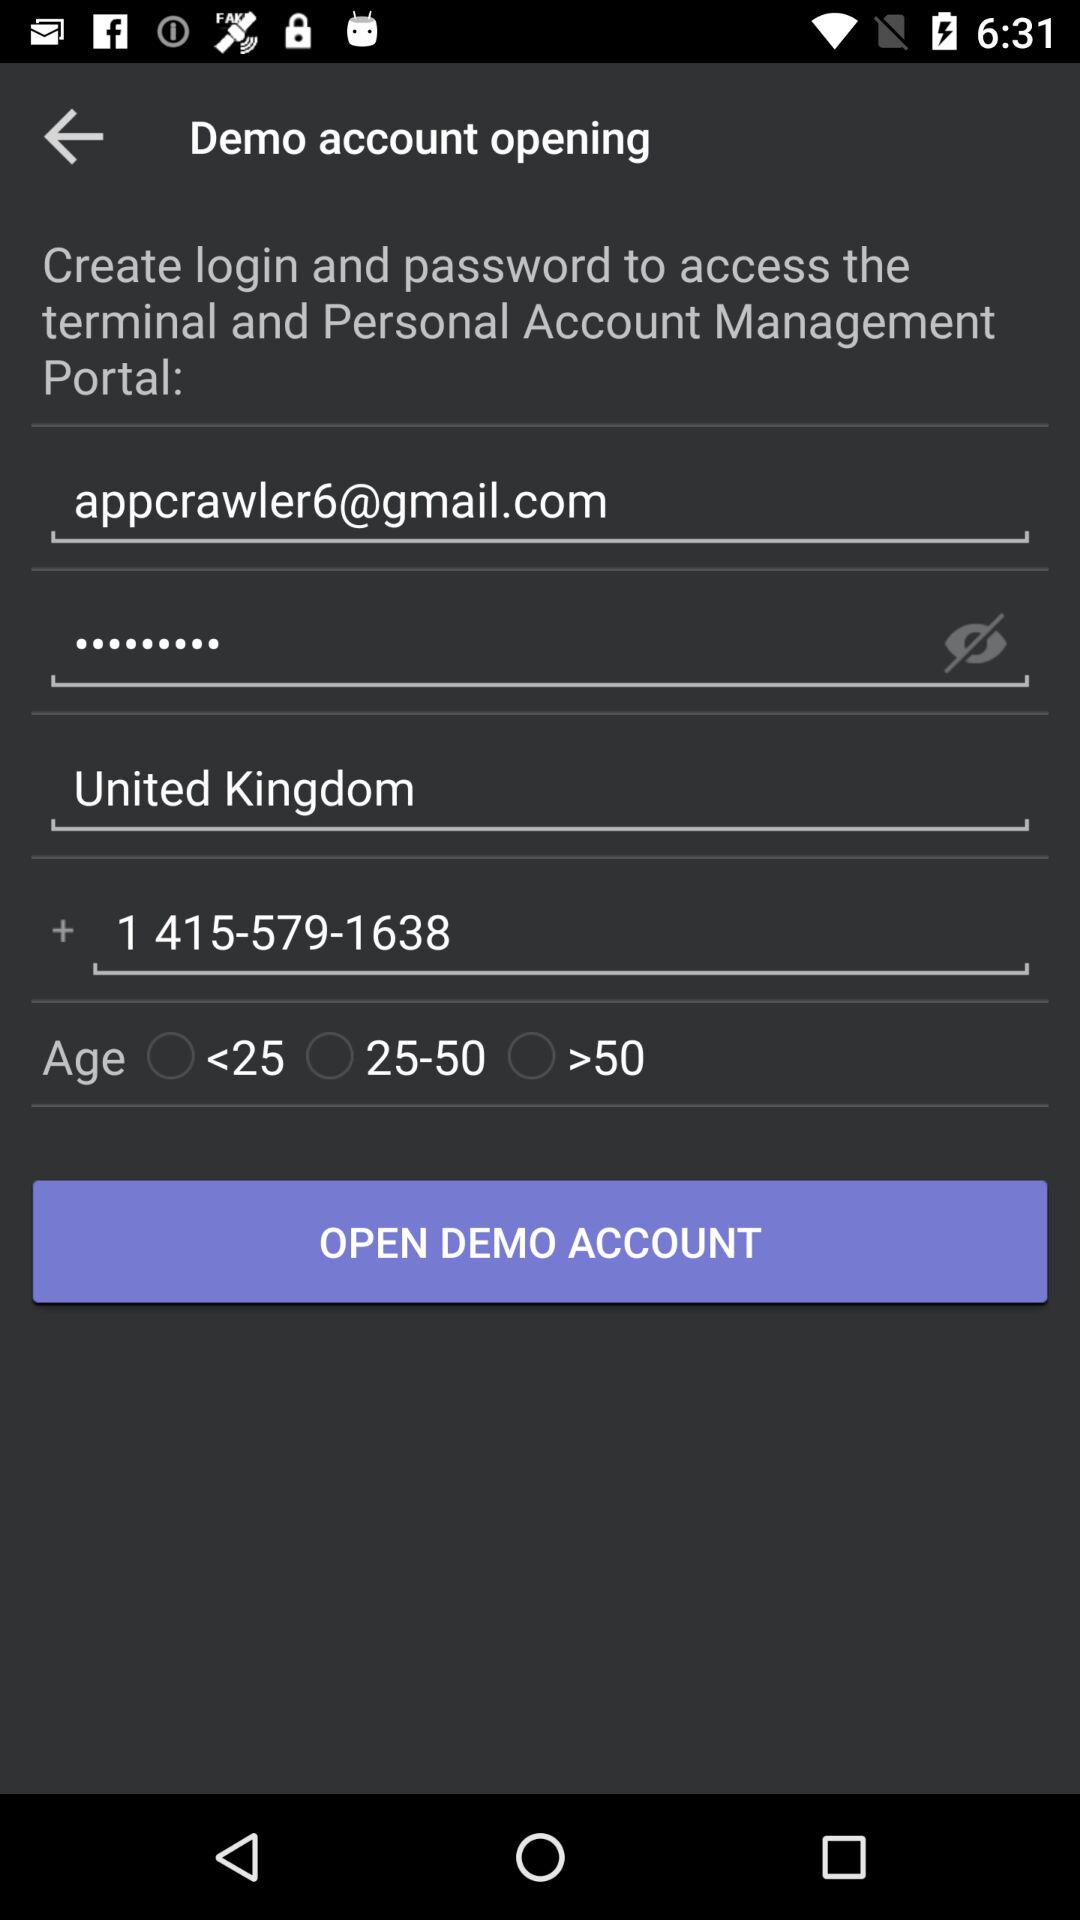What is the contact number? The contact number is +1 415-579-1638. 